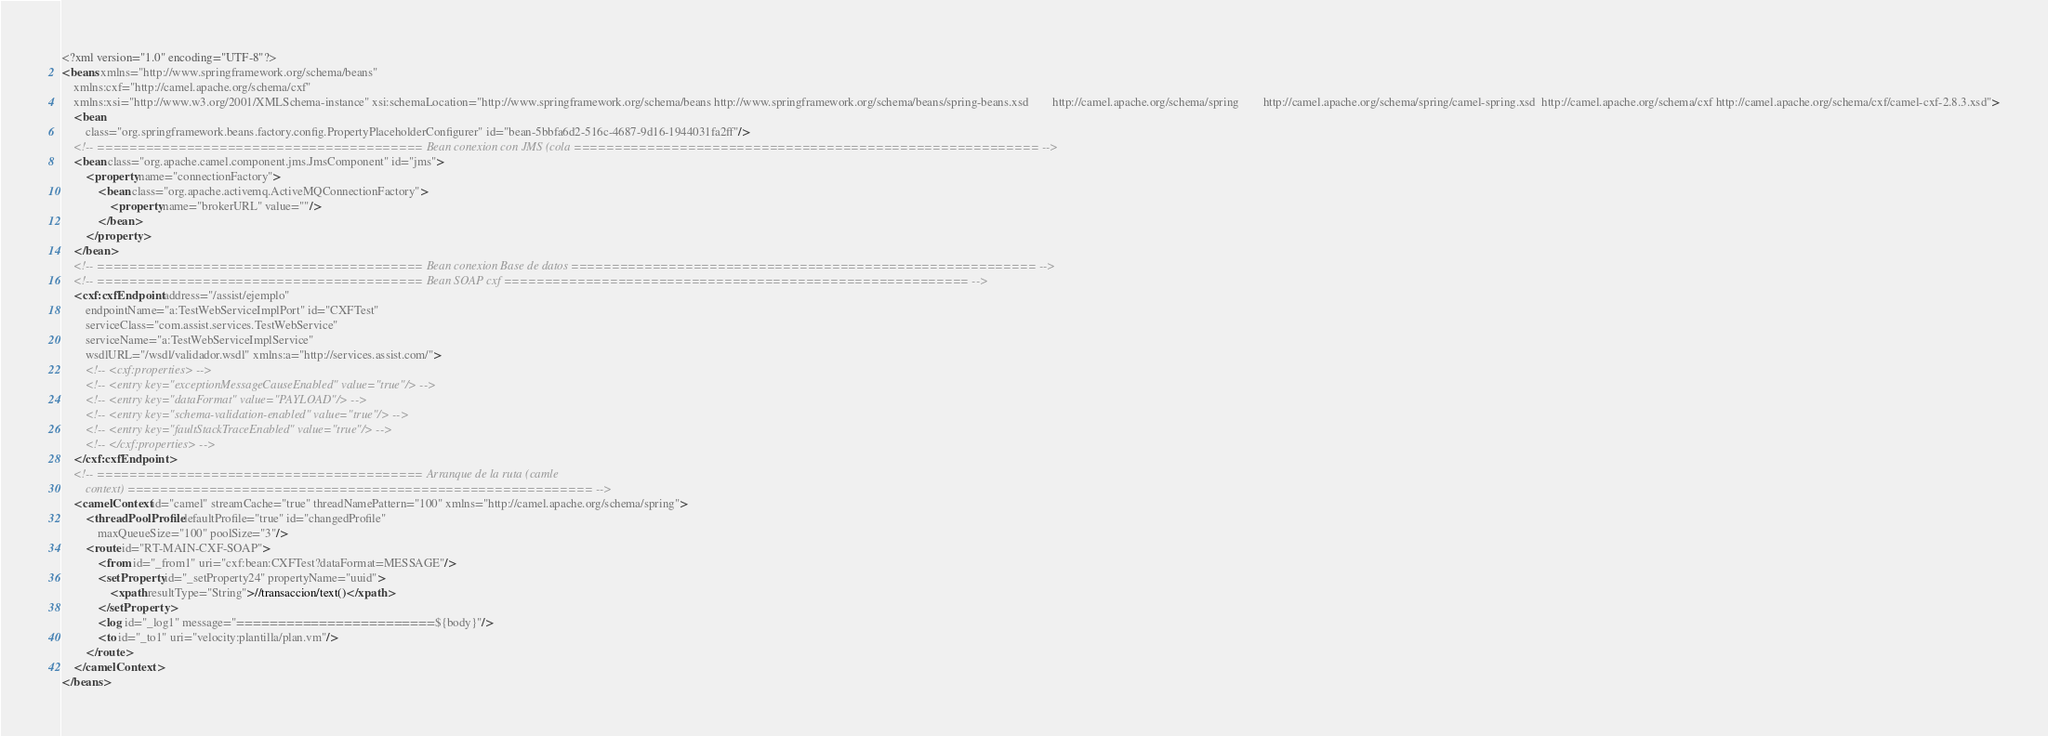<code> <loc_0><loc_0><loc_500><loc_500><_XML_><?xml version="1.0" encoding="UTF-8"?>
<beans xmlns="http://www.springframework.org/schema/beans"
    xmlns:cxf="http://camel.apache.org/schema/cxf"
    xmlns:xsi="http://www.w3.org/2001/XMLSchema-instance" xsi:schemaLocation="http://www.springframework.org/schema/beans http://www.springframework.org/schema/beans/spring-beans.xsd        http://camel.apache.org/schema/spring        http://camel.apache.org/schema/spring/camel-spring.xsd  http://camel.apache.org/schema/cxf http://camel.apache.org/schema/cxf/camel-cxf-2.8.3.xsd">
    <bean
        class="org.springframework.beans.factory.config.PropertyPlaceholderConfigurer" id="bean-5bbfa6d2-516c-4687-9d16-1944031fa2ff"/>
    <!-- ======================================== Bean conexion con JMS (cola ========================================================= -->
    <bean class="org.apache.camel.component.jms.JmsComponent" id="jms">
        <property name="connectionFactory">
            <bean class="org.apache.activemq.ActiveMQConnectionFactory">
                <property name="brokerURL" value=""/>
            </bean>
        </property>
    </bean>
    <!-- ======================================== Bean conexion Base de datos ========================================================= -->
    <!-- ======================================== Bean SOAP cxf ========================================================= -->
    <cxf:cxfEndpoint address="/assist/ejemplo"
        endpointName="a:TestWebServiceImplPort" id="CXFTest"
        serviceClass="com.assist.services.TestWebService"
        serviceName="a:TestWebServiceImplService"
        wsdlURL="/wsdl/validador.wsdl" xmlns:a="http://services.assist.com/">
        <!-- <cxf:properties> -->
        <!-- <entry key="exceptionMessageCauseEnabled" value="true"/> -->
        <!-- <entry key="dataFormat" value="PAYLOAD"/> -->
        <!-- <entry key="schema-validation-enabled" value="true"/> -->
        <!-- <entry key="faultStackTraceEnabled" value="true"/> -->
        <!-- </cxf:properties> -->
    </cxf:cxfEndpoint>
    <!-- ======================================== Arranque de la ruta (camle 
		context) ========================================================= -->
    <camelContext id="camel" streamCache="true" threadNamePattern="100" xmlns="http://camel.apache.org/schema/spring">
        <threadPoolProfile defaultProfile="true" id="changedProfile"
            maxQueueSize="100" poolSize="3"/>
        <route id="RT-MAIN-CXF-SOAP">
            <from id="_from1" uri="cxf:bean:CXFTest?dataFormat=MESSAGE"/>
            <setProperty id="_setProperty24" propertyName="uuid">
                <xpath resultType="String">//transaccion/text()</xpath>
            </setProperty>
            <log id="_log1" message="========================${body}"/>
            <to id="_to1" uri="velocity:plantilla/plan.vm"/>
        </route>
    </camelContext>
</beans>
</code> 